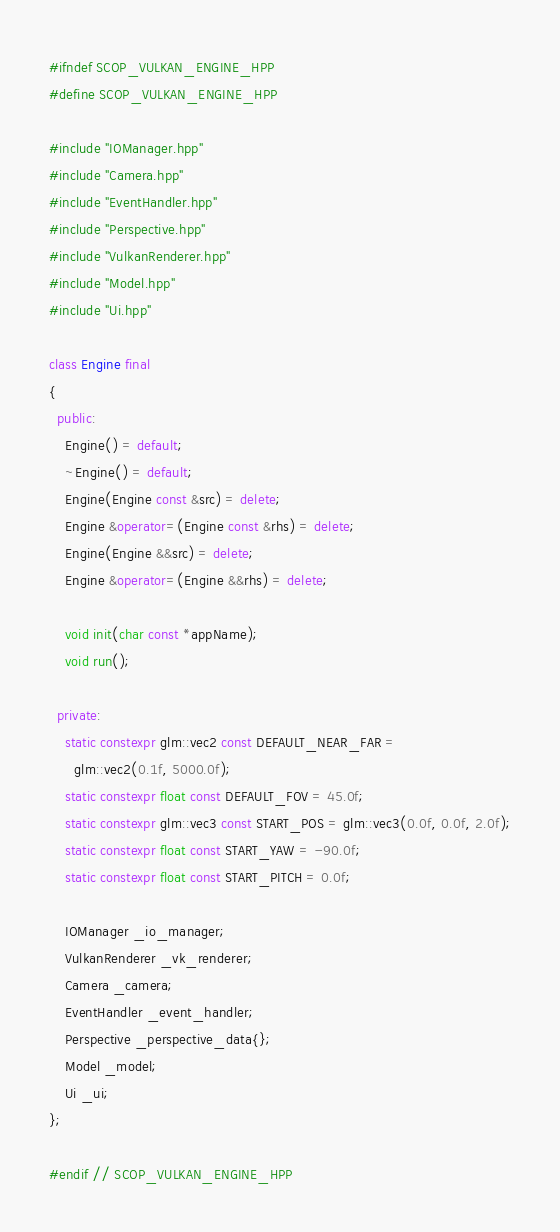<code> <loc_0><loc_0><loc_500><loc_500><_C++_>#ifndef SCOP_VULKAN_ENGINE_HPP
#define SCOP_VULKAN_ENGINE_HPP

#include "IOManager.hpp"
#include "Camera.hpp"
#include "EventHandler.hpp"
#include "Perspective.hpp"
#include "VulkanRenderer.hpp"
#include "Model.hpp"
#include "Ui.hpp"

class Engine final
{
  public:
    Engine() = default;
    ~Engine() = default;
    Engine(Engine const &src) = delete;
    Engine &operator=(Engine const &rhs) = delete;
    Engine(Engine &&src) = delete;
    Engine &operator=(Engine &&rhs) = delete;

    void init(char const *appName);
    void run();

  private:
    static constexpr glm::vec2 const DEFAULT_NEAR_FAR =
      glm::vec2(0.1f, 5000.0f);
    static constexpr float const DEFAULT_FOV = 45.0f;
    static constexpr glm::vec3 const START_POS = glm::vec3(0.0f, 0.0f, 2.0f);
    static constexpr float const START_YAW = -90.0f;
    static constexpr float const START_PITCH = 0.0f;

    IOManager _io_manager;
    VulkanRenderer _vk_renderer;
    Camera _camera;
    EventHandler _event_handler;
    Perspective _perspective_data{};
    Model _model;
    Ui _ui;
};

#endif // SCOP_VULKAN_ENGINE_HPP</code> 